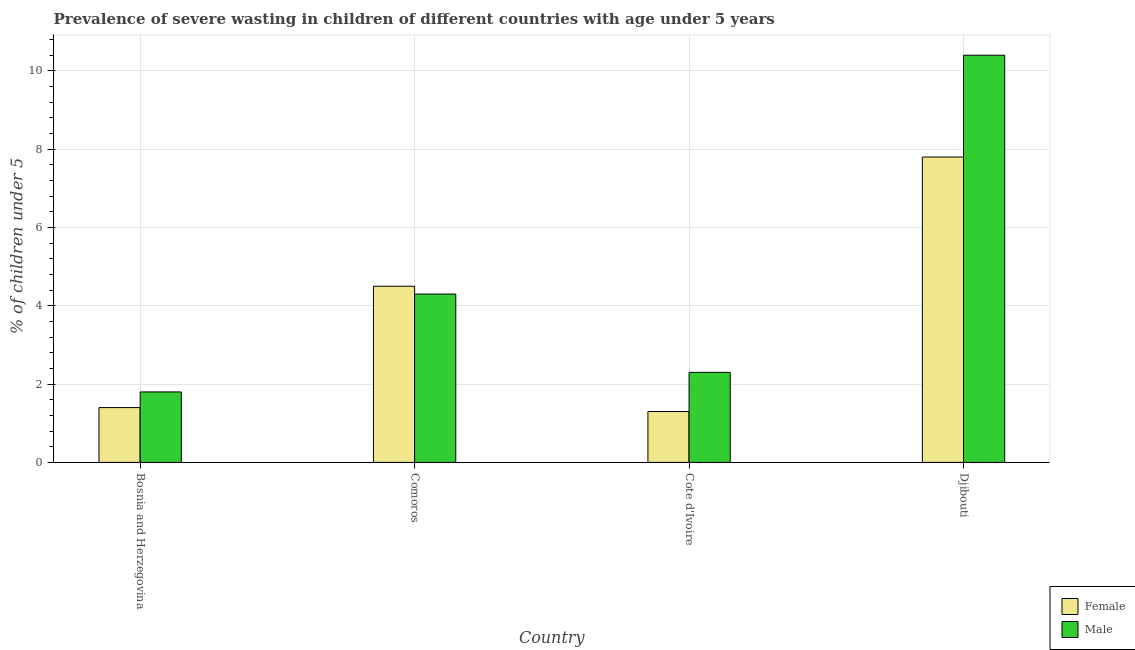Are the number of bars per tick equal to the number of legend labels?
Your answer should be compact. Yes. Are the number of bars on each tick of the X-axis equal?
Your answer should be very brief. Yes. What is the label of the 3rd group of bars from the left?
Make the answer very short. Cote d'Ivoire. In how many cases, is the number of bars for a given country not equal to the number of legend labels?
Give a very brief answer. 0. What is the percentage of undernourished male children in Djibouti?
Your answer should be very brief. 10.4. Across all countries, what is the maximum percentage of undernourished female children?
Your response must be concise. 7.8. Across all countries, what is the minimum percentage of undernourished female children?
Your answer should be very brief. 1.3. In which country was the percentage of undernourished female children maximum?
Offer a terse response. Djibouti. In which country was the percentage of undernourished female children minimum?
Your answer should be very brief. Cote d'Ivoire. What is the total percentage of undernourished male children in the graph?
Ensure brevity in your answer.  18.8. What is the difference between the percentage of undernourished male children in Comoros and that in Cote d'Ivoire?
Your response must be concise. 2. What is the difference between the percentage of undernourished female children in Comoros and the percentage of undernourished male children in Cote d'Ivoire?
Provide a succinct answer. 2.2. What is the average percentage of undernourished male children per country?
Your answer should be very brief. 4.7. What is the difference between the percentage of undernourished female children and percentage of undernourished male children in Djibouti?
Provide a short and direct response. -2.6. In how many countries, is the percentage of undernourished male children greater than 8.4 %?
Offer a terse response. 1. What is the ratio of the percentage of undernourished male children in Bosnia and Herzegovina to that in Cote d'Ivoire?
Keep it short and to the point. 0.78. Is the difference between the percentage of undernourished male children in Cote d'Ivoire and Djibouti greater than the difference between the percentage of undernourished female children in Cote d'Ivoire and Djibouti?
Your answer should be very brief. No. What is the difference between the highest and the second highest percentage of undernourished male children?
Ensure brevity in your answer.  6.1. What is the difference between the highest and the lowest percentage of undernourished female children?
Your answer should be very brief. 6.5. What does the 2nd bar from the right in Comoros represents?
Your answer should be compact. Female. Are the values on the major ticks of Y-axis written in scientific E-notation?
Make the answer very short. No. Does the graph contain any zero values?
Ensure brevity in your answer.  No. Does the graph contain grids?
Make the answer very short. Yes. Where does the legend appear in the graph?
Your answer should be compact. Bottom right. What is the title of the graph?
Make the answer very short. Prevalence of severe wasting in children of different countries with age under 5 years. Does "Female labor force" appear as one of the legend labels in the graph?
Your answer should be compact. No. What is the label or title of the X-axis?
Your answer should be compact. Country. What is the label or title of the Y-axis?
Your answer should be compact.  % of children under 5. What is the  % of children under 5 in Female in Bosnia and Herzegovina?
Provide a succinct answer. 1.4. What is the  % of children under 5 in Male in Bosnia and Herzegovina?
Make the answer very short. 1.8. What is the  % of children under 5 of Female in Comoros?
Your response must be concise. 4.5. What is the  % of children under 5 in Male in Comoros?
Give a very brief answer. 4.3. What is the  % of children under 5 in Female in Cote d'Ivoire?
Offer a very short reply. 1.3. What is the  % of children under 5 of Male in Cote d'Ivoire?
Provide a short and direct response. 2.3. What is the  % of children under 5 of Female in Djibouti?
Provide a short and direct response. 7.8. What is the  % of children under 5 in Male in Djibouti?
Your answer should be very brief. 10.4. Across all countries, what is the maximum  % of children under 5 in Female?
Keep it short and to the point. 7.8. Across all countries, what is the maximum  % of children under 5 of Male?
Your answer should be very brief. 10.4. Across all countries, what is the minimum  % of children under 5 in Female?
Ensure brevity in your answer.  1.3. Across all countries, what is the minimum  % of children under 5 in Male?
Provide a succinct answer. 1.8. What is the total  % of children under 5 of Female in the graph?
Keep it short and to the point. 15. What is the difference between the  % of children under 5 in Male in Bosnia and Herzegovina and that in Comoros?
Your response must be concise. -2.5. What is the difference between the  % of children under 5 of Female in Bosnia and Herzegovina and that in Cote d'Ivoire?
Ensure brevity in your answer.  0.1. What is the difference between the  % of children under 5 in Female in Comoros and that in Cote d'Ivoire?
Provide a succinct answer. 3.2. What is the difference between the  % of children under 5 in Male in Comoros and that in Cote d'Ivoire?
Make the answer very short. 2. What is the difference between the  % of children under 5 in Male in Comoros and that in Djibouti?
Offer a very short reply. -6.1. What is the difference between the  % of children under 5 in Female in Cote d'Ivoire and that in Djibouti?
Offer a very short reply. -6.5. What is the difference between the  % of children under 5 of Female in Bosnia and Herzegovina and the  % of children under 5 of Male in Djibouti?
Your answer should be very brief. -9. What is the difference between the  % of children under 5 in Female in Comoros and the  % of children under 5 in Male in Djibouti?
Offer a very short reply. -5.9. What is the average  % of children under 5 of Female per country?
Ensure brevity in your answer.  3.75. What is the average  % of children under 5 of Male per country?
Your answer should be very brief. 4.7. What is the difference between the  % of children under 5 of Female and  % of children under 5 of Male in Bosnia and Herzegovina?
Provide a succinct answer. -0.4. What is the difference between the  % of children under 5 of Female and  % of children under 5 of Male in Comoros?
Offer a very short reply. 0.2. What is the ratio of the  % of children under 5 in Female in Bosnia and Herzegovina to that in Comoros?
Offer a very short reply. 0.31. What is the ratio of the  % of children under 5 in Male in Bosnia and Herzegovina to that in Comoros?
Your response must be concise. 0.42. What is the ratio of the  % of children under 5 in Male in Bosnia and Herzegovina to that in Cote d'Ivoire?
Your answer should be very brief. 0.78. What is the ratio of the  % of children under 5 in Female in Bosnia and Herzegovina to that in Djibouti?
Provide a succinct answer. 0.18. What is the ratio of the  % of children under 5 in Male in Bosnia and Herzegovina to that in Djibouti?
Offer a terse response. 0.17. What is the ratio of the  % of children under 5 in Female in Comoros to that in Cote d'Ivoire?
Offer a terse response. 3.46. What is the ratio of the  % of children under 5 of Male in Comoros to that in Cote d'Ivoire?
Give a very brief answer. 1.87. What is the ratio of the  % of children under 5 in Female in Comoros to that in Djibouti?
Your response must be concise. 0.58. What is the ratio of the  % of children under 5 in Male in Comoros to that in Djibouti?
Make the answer very short. 0.41. What is the ratio of the  % of children under 5 of Male in Cote d'Ivoire to that in Djibouti?
Provide a short and direct response. 0.22. What is the difference between the highest and the second highest  % of children under 5 of Male?
Provide a short and direct response. 6.1. What is the difference between the highest and the lowest  % of children under 5 in Male?
Your response must be concise. 8.6. 